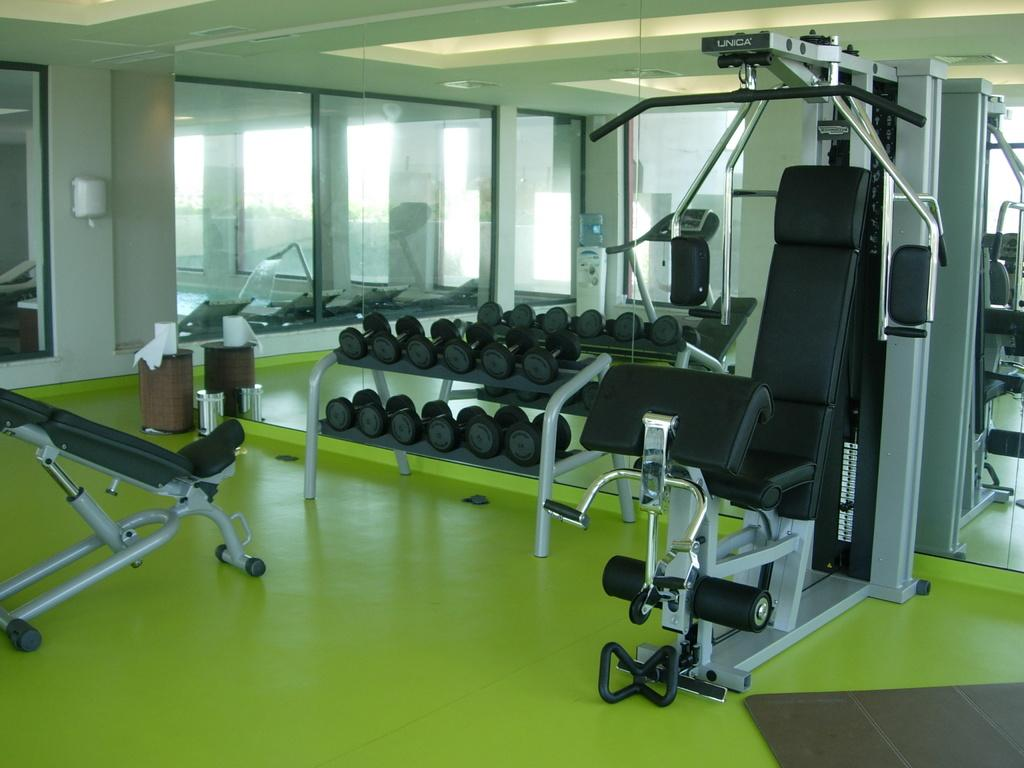What type of equipment can be seen in the image? There are gym equipment in the image. Can you identify any specific gym equipment in the image? Yes, there are dumbbells in the image. What else can be seen in the image besides gym equipment? There are tissue rolls in the image. What is the color of the floor in the image? The color of the floor is green. Is there a hill visible in the image? No, there is no hill present in the image. 